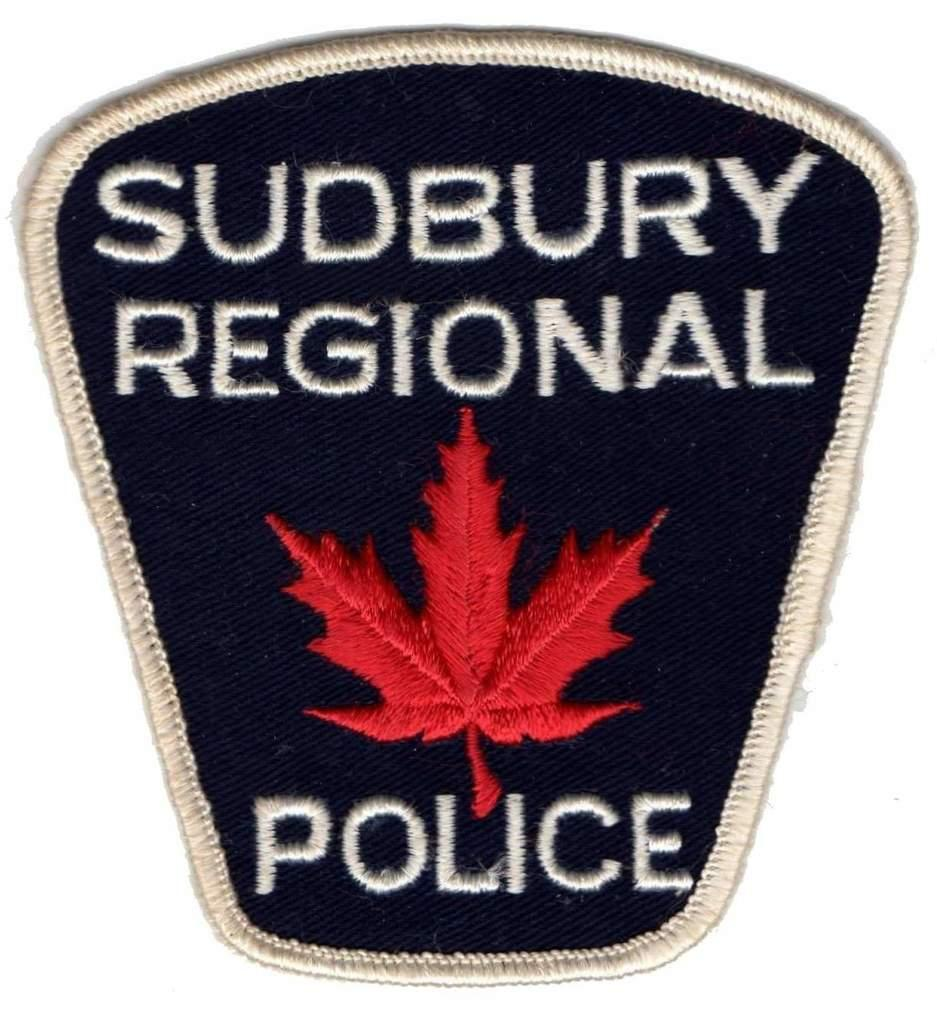What object can be seen in the picture? There is a badge in the picture. What is written on the badge? The badge has text on it. What else is featured on the badge besides the text? The badge has a logo on it. How does the tramp contribute to the design of the badge? There is no tramp present in the image or mentioned in the facts provided. The badge features text and a logo, but no tramp is involved. 